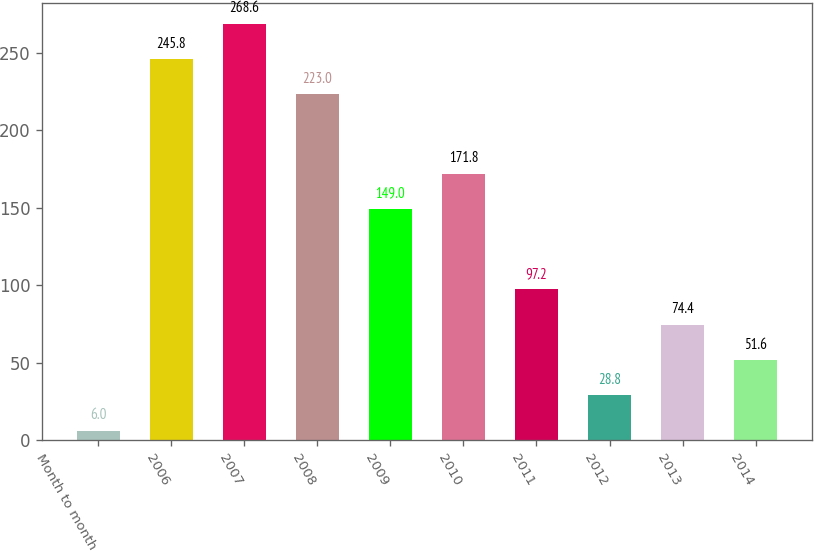<chart> <loc_0><loc_0><loc_500><loc_500><bar_chart><fcel>Month to month<fcel>2006<fcel>2007<fcel>2008<fcel>2009<fcel>2010<fcel>2011<fcel>2012<fcel>2013<fcel>2014<nl><fcel>6<fcel>245.8<fcel>268.6<fcel>223<fcel>149<fcel>171.8<fcel>97.2<fcel>28.8<fcel>74.4<fcel>51.6<nl></chart> 